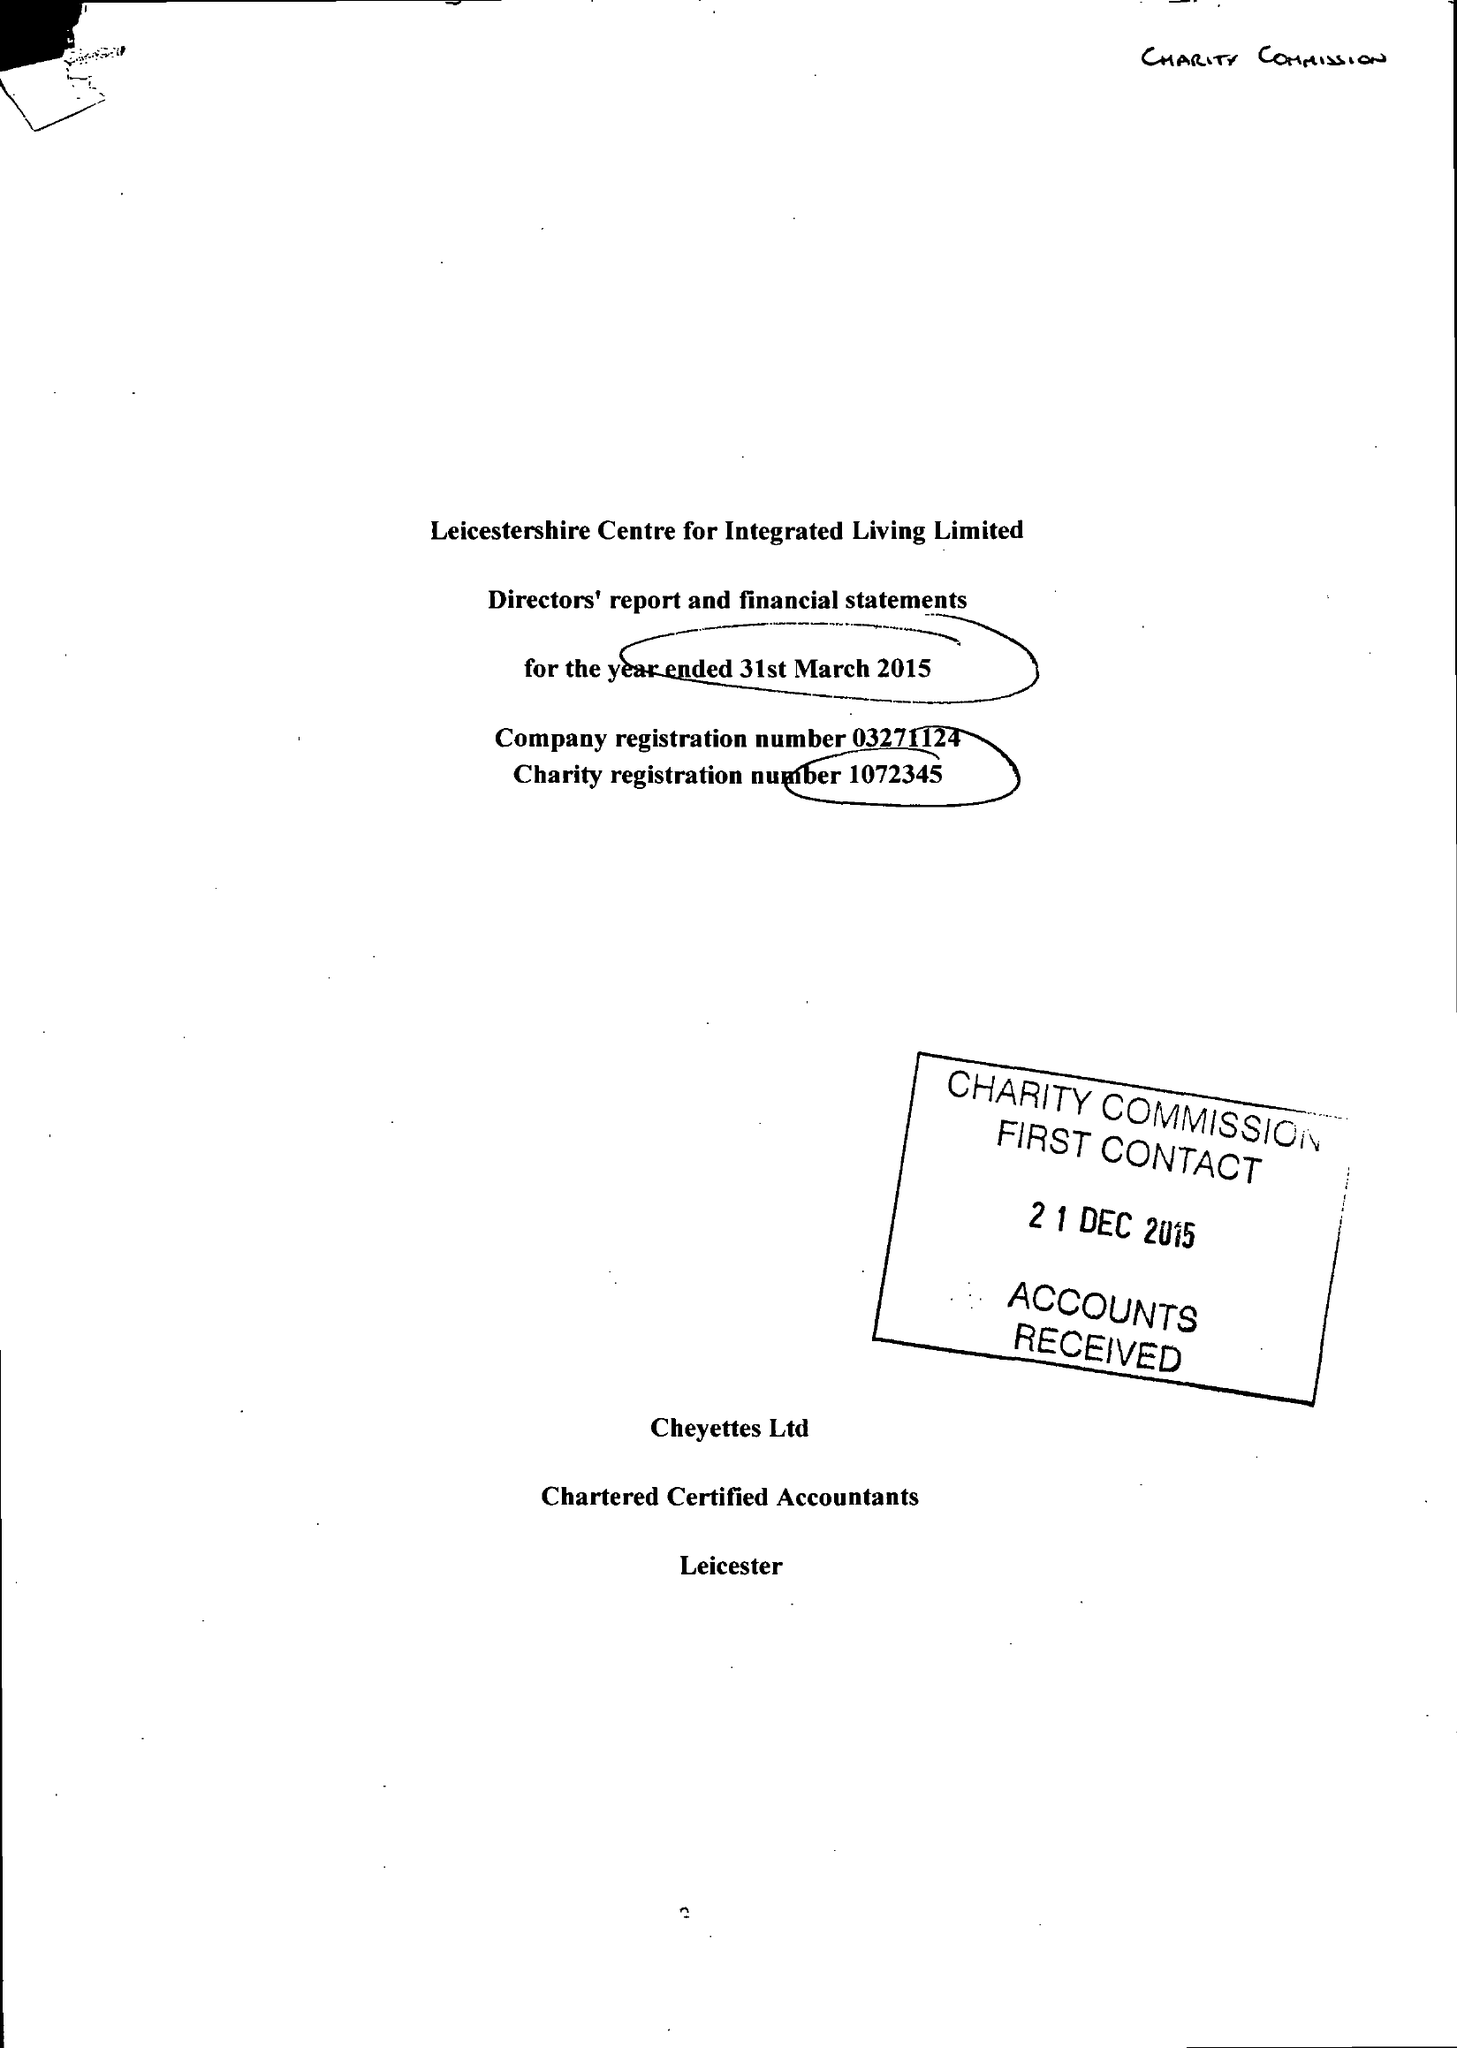What is the value for the report_date?
Answer the question using a single word or phrase. 2015-03-31 